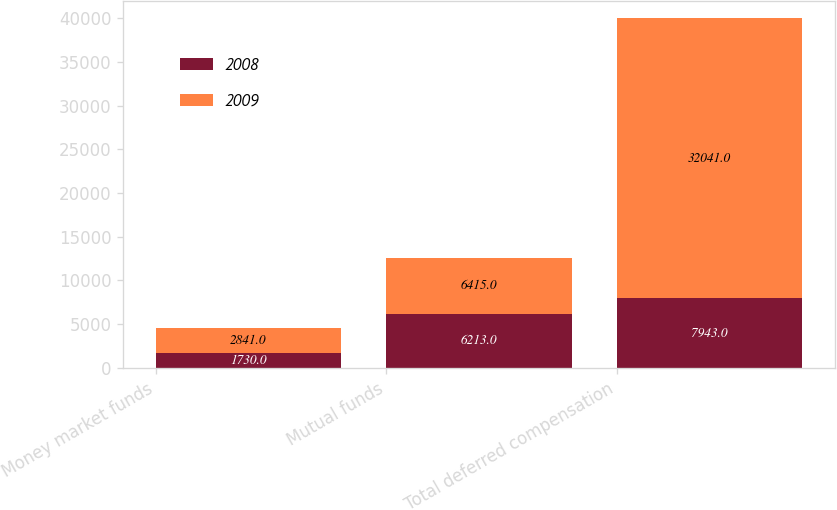Convert chart. <chart><loc_0><loc_0><loc_500><loc_500><stacked_bar_chart><ecel><fcel>Money market funds<fcel>Mutual funds<fcel>Total deferred compensation<nl><fcel>2008<fcel>1730<fcel>6213<fcel>7943<nl><fcel>2009<fcel>2841<fcel>6415<fcel>32041<nl></chart> 